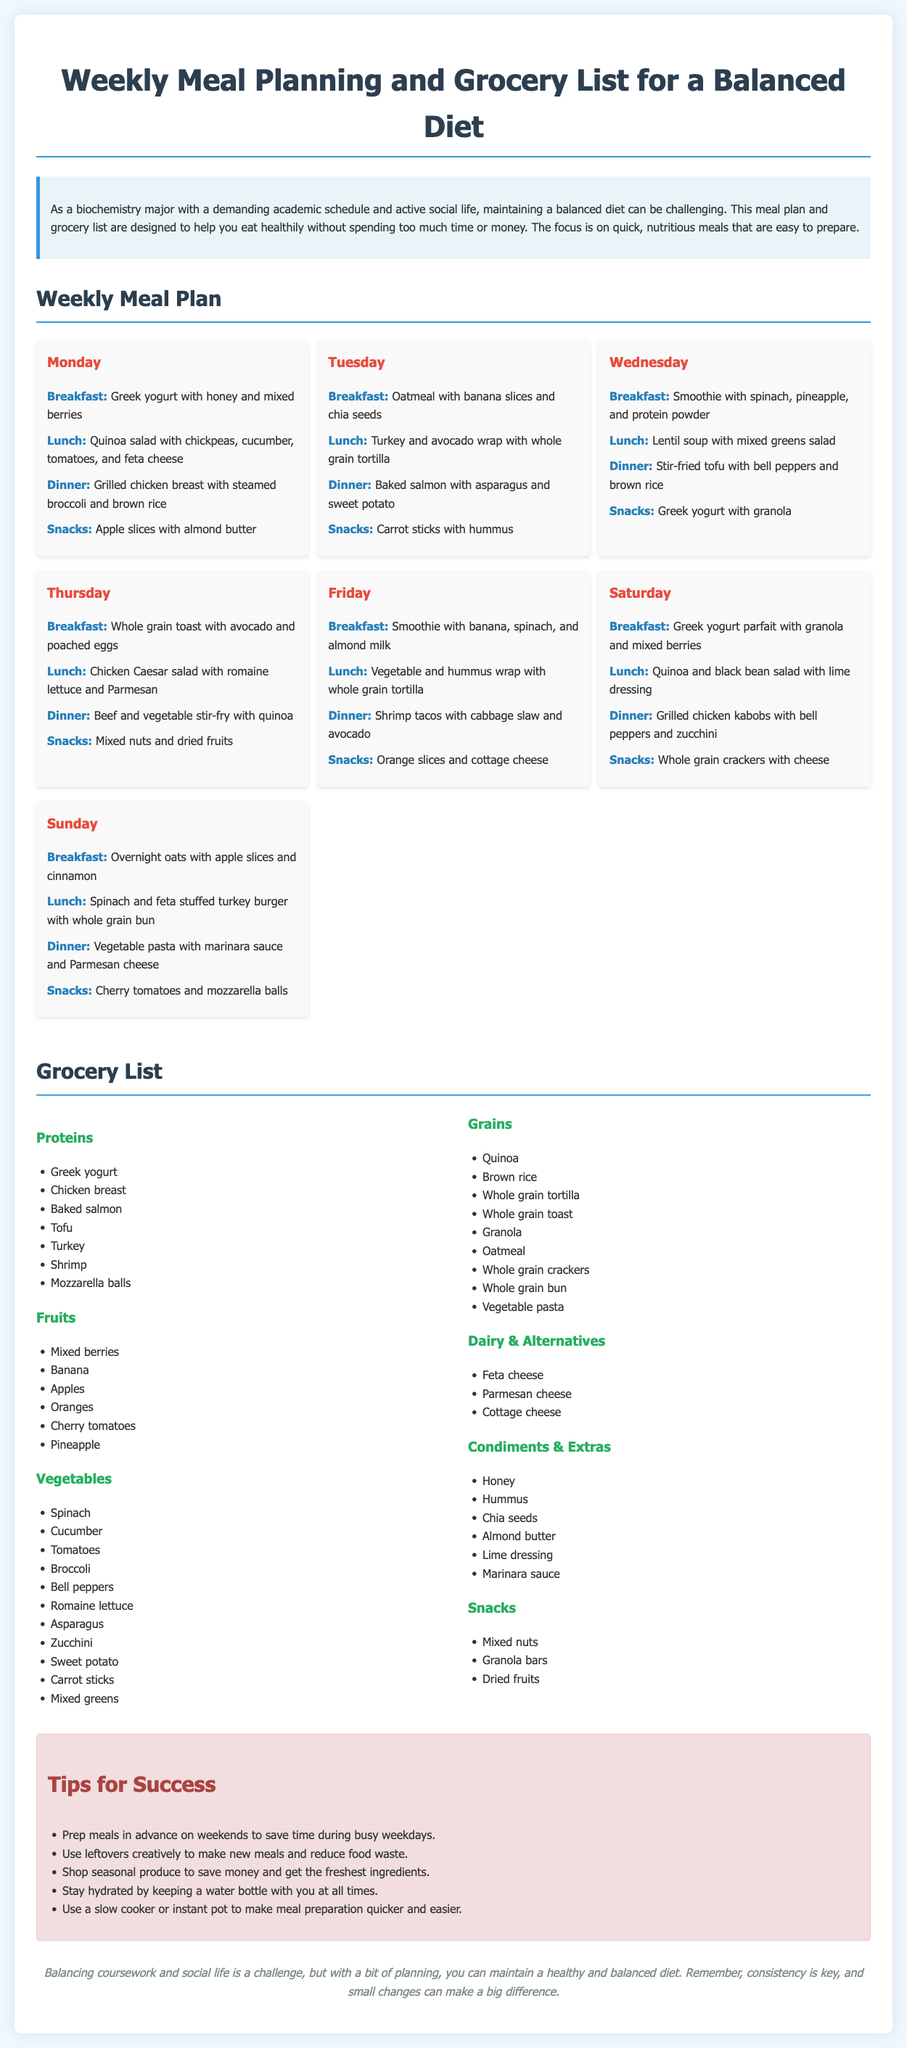what is the main focus of the meal plan? The meal plan focuses on helping individuals eat healthily without spending too much time or money.
Answer: healthy eating how many meals are planned for each day? Each day includes four meals: breakfast, lunch, dinner, and snacks.
Answer: four meals what type of snack is included for Monday? The snack for Monday is apple slices with almond butter.
Answer: apple slices with almond butter which protein is listed for Friday's dinner? The protein listed for Friday's dinner is shrimp.
Answer: shrimp what type of dairy is included in the grocery list? The grocery list includes feta cheese, Parmesan cheese, and cottage cheese.
Answer: feta cheese, Parmesan cheese, cottage cheese how can one save time during busy weekdays? One can prep meals in advance on weekends to save time.
Answer: prep meals in advance which day features a vegetarian dinner option? Wednesday features a vegetarian dinner option with stir-fried tofu.
Answer: Wednesday what is advised to stay hydrated? It is advised to keep a water bottle with you at all times.
Answer: water bottle how many categories are in the grocery list? There are six categories in the grocery list.
Answer: six categories 